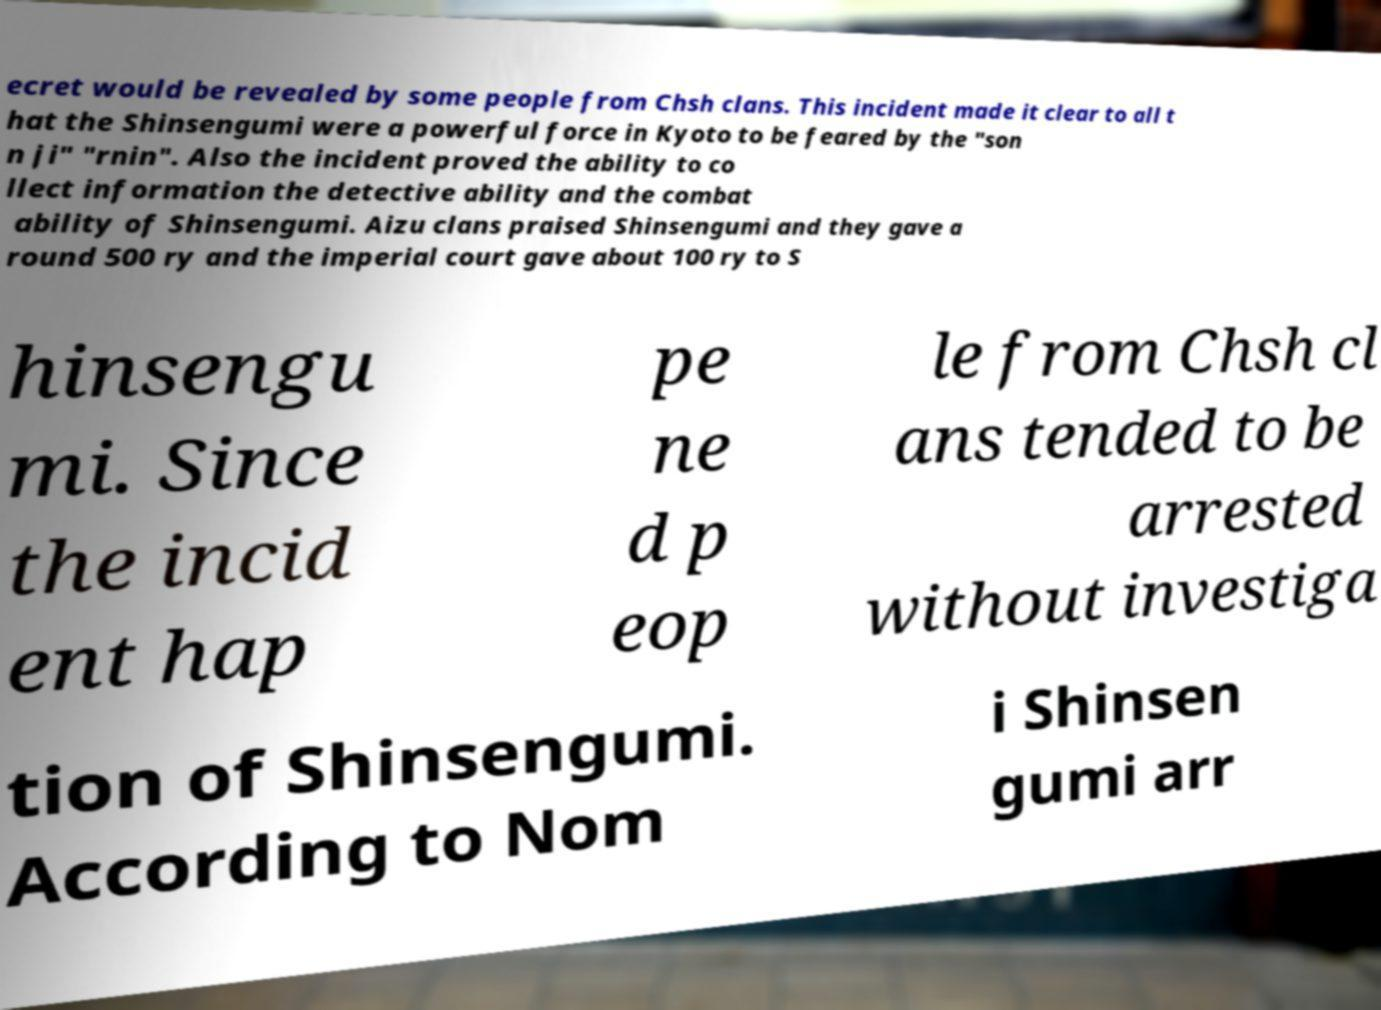Please read and relay the text visible in this image. What does it say? ecret would be revealed by some people from Chsh clans. This incident made it clear to all t hat the Shinsengumi were a powerful force in Kyoto to be feared by the "son n ji" "rnin". Also the incident proved the ability to co llect information the detective ability and the combat ability of Shinsengumi. Aizu clans praised Shinsengumi and they gave a round 500 ry and the imperial court gave about 100 ry to S hinsengu mi. Since the incid ent hap pe ne d p eop le from Chsh cl ans tended to be arrested without investiga tion of Shinsengumi. According to Nom i Shinsen gumi arr 